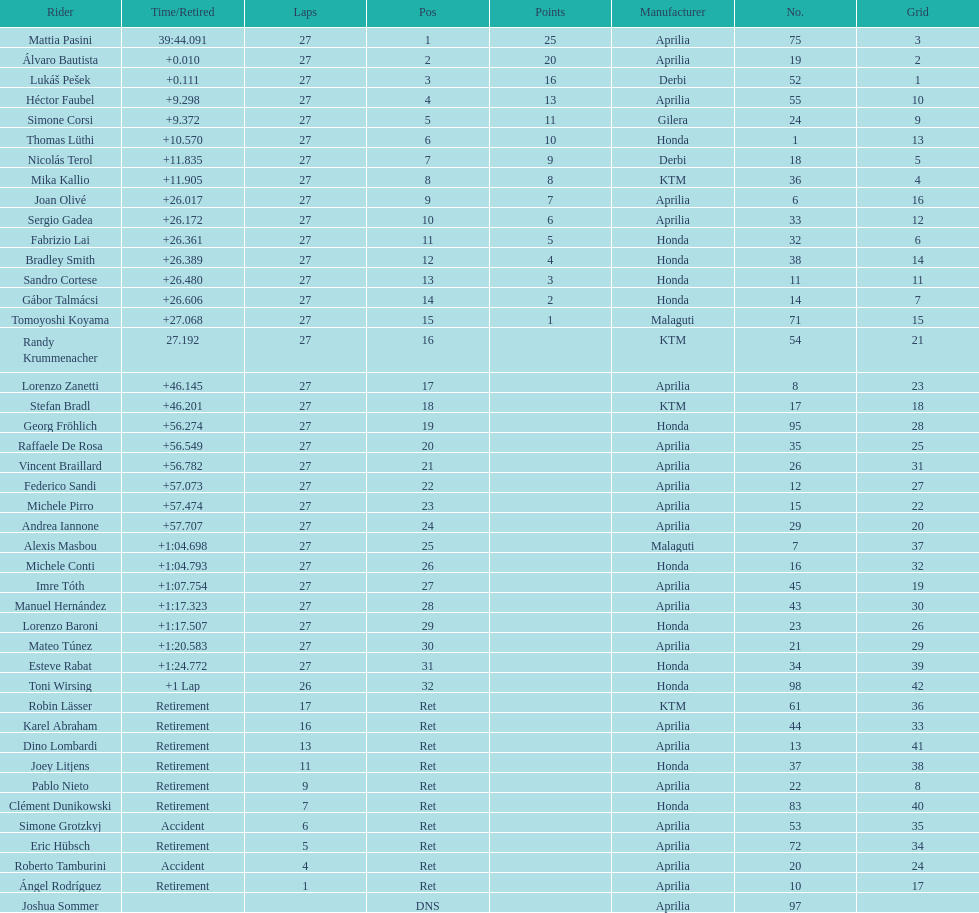Who placed higher, bradl or gadea? Sergio Gadea. 